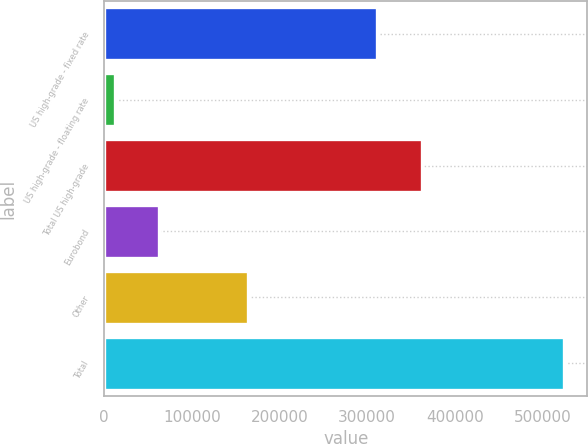<chart> <loc_0><loc_0><loc_500><loc_500><bar_chart><fcel>US high-grade - fixed rate<fcel>US high-grade - floating rate<fcel>Total US high-grade<fcel>Eurobond<fcel>Other<fcel>Total<nl><fcel>311758<fcel>11802<fcel>363078<fcel>63122.5<fcel>164514<fcel>525007<nl></chart> 